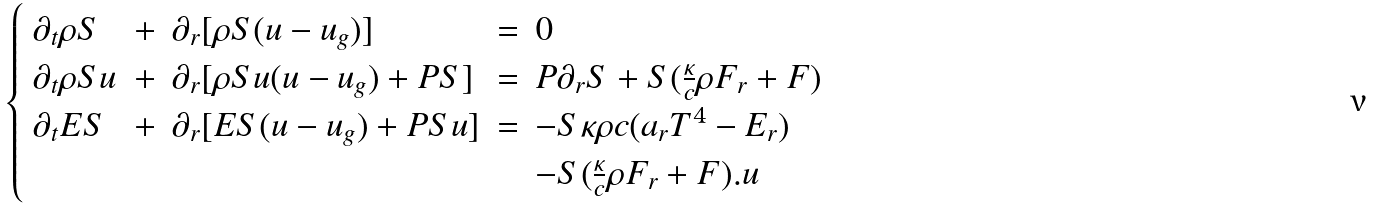<formula> <loc_0><loc_0><loc_500><loc_500>\begin{cases} \begin{array} { l l l l l } \partial _ { t } \rho S & + & \partial _ { r } [ \rho S ( u - u _ { g } ) ] & = & 0 \\ \partial _ { t } \rho S u & + & \partial _ { r } [ \rho S u ( u - u _ { g } ) + P S ] & = & P \partial _ { r } S + S ( \frac { \kappa } { c } \rho F _ { r } + F ) \\ \partial _ { t } E S & + & \partial _ { r } [ E S ( u - u _ { g } ) + P S u ] & = & - S \kappa \rho c ( a _ { r } T ^ { 4 } - E _ { r } ) \\ & & & & - S ( \frac { \kappa } { c } \rho F _ { r } + F ) . u \end{array} \end{cases}</formula> 